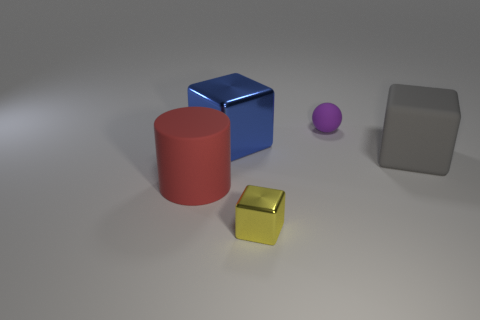There is a blue block that is the same size as the gray matte cube; what material is it?
Give a very brief answer. Metal. There is a small thing that is in front of the metal cube behind the cylinder that is in front of the rubber cube; what is its shape?
Your answer should be very brief. Cube. There is a yellow metal object that is the same size as the sphere; what shape is it?
Provide a succinct answer. Cube. How many gray blocks are behind the large cube that is left of the metallic object that is in front of the large red cylinder?
Offer a terse response. 0. Are there more big rubber cylinders that are behind the yellow shiny cube than large objects to the right of the big blue metallic thing?
Offer a very short reply. No. What number of small yellow objects are the same shape as the red matte thing?
Offer a terse response. 0. How many objects are either large matte things to the left of the sphere or big objects that are behind the matte cylinder?
Provide a short and direct response. 3. What material is the thing in front of the big matte object that is on the left side of the metallic cube in front of the gray block?
Offer a terse response. Metal. There is a big object on the right side of the big metallic block; is its color the same as the tiny rubber sphere?
Your answer should be compact. No. The big object that is in front of the big blue object and to the right of the matte cylinder is made of what material?
Provide a succinct answer. Rubber. 